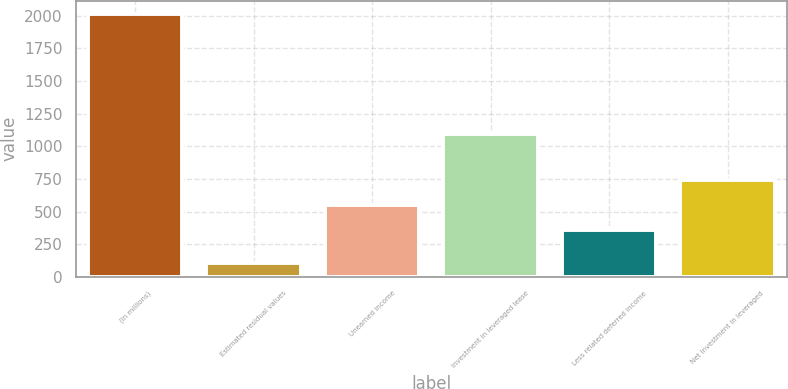Convert chart. <chart><loc_0><loc_0><loc_500><loc_500><bar_chart><fcel>(In millions)<fcel>Estimated residual values<fcel>Unearned income<fcel>Investment in leveraged lease<fcel>Less related deferred income<fcel>Net investment in leveraged<nl><fcel>2013<fcel>110<fcel>549.3<fcel>1095<fcel>359<fcel>739.6<nl></chart> 